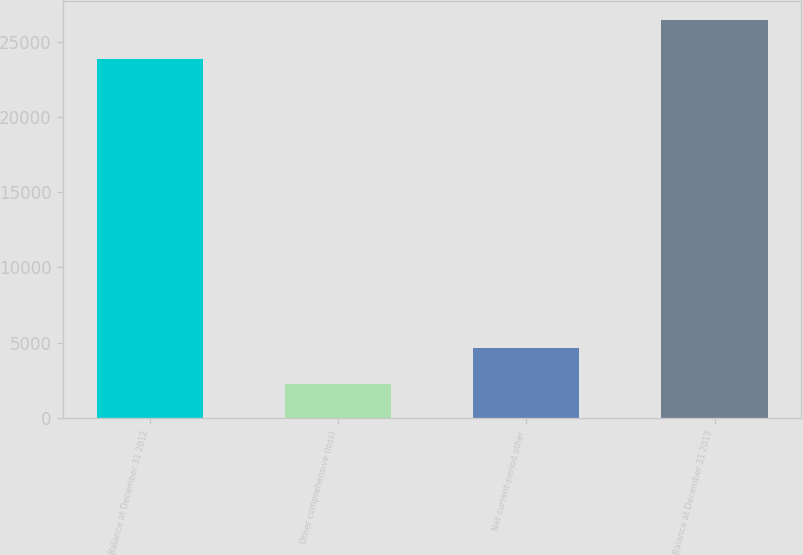Convert chart to OTSL. <chart><loc_0><loc_0><loc_500><loc_500><bar_chart><fcel>Balance at December 31 2012<fcel>Other comprehensive (loss)<fcel>Net current-period other<fcel>Balance at December 31 2013<nl><fcel>23861<fcel>2237<fcel>4656<fcel>26427<nl></chart> 